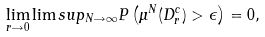<formula> <loc_0><loc_0><loc_500><loc_500>\lim _ { r \rightarrow 0 } { \lim s u p _ { N \rightarrow \infty } { P \left ( \mu ^ { N } ( D _ { r } ^ { c } ) > \epsilon \right ) } } = 0 ,</formula> 